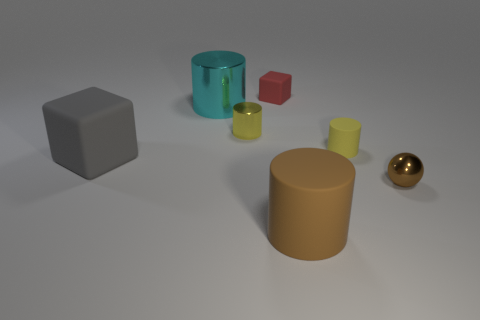Add 1 rubber blocks. How many objects exist? 8 Subtract all cylinders. How many objects are left? 3 Subtract all large brown matte blocks. Subtract all small metal cylinders. How many objects are left? 6 Add 2 brown balls. How many brown balls are left? 3 Add 4 cyan metal things. How many cyan metal things exist? 5 Subtract 0 blue spheres. How many objects are left? 7 